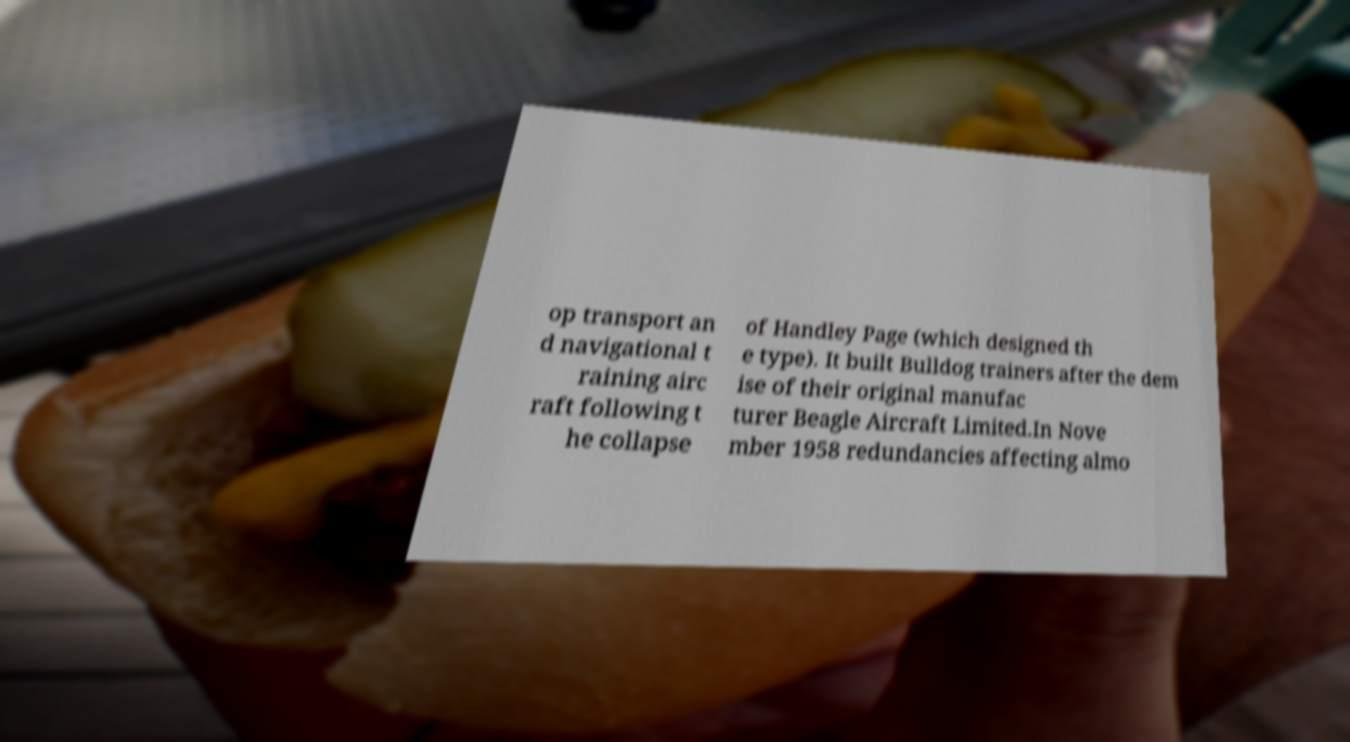Can you accurately transcribe the text from the provided image for me? op transport an d navigational t raining airc raft following t he collapse of Handley Page (which designed th e type). It built Bulldog trainers after the dem ise of their original manufac turer Beagle Aircraft Limited.In Nove mber 1958 redundancies affecting almo 